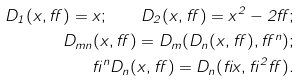Convert formula to latex. <formula><loc_0><loc_0><loc_500><loc_500>D _ { 1 } ( x , \alpha ) = x ; \quad D _ { 2 } ( x , \alpha ) = x ^ { 2 } - 2 \alpha ; \\ D _ { m n } ( x , \alpha ) = D _ { m } ( D _ { n } ( x , \alpha ) , \alpha ^ { n } ) ; \\ \beta ^ { n } D _ { n } ( x , \alpha ) = D _ { n } ( \beta x , \beta ^ { 2 } \alpha ) .</formula> 